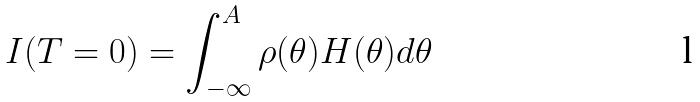<formula> <loc_0><loc_0><loc_500><loc_500>I ( T = 0 ) = \int _ { - \infty } ^ { A } \rho ( \theta ) H ( \theta ) d \theta</formula> 